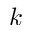<formula> <loc_0><loc_0><loc_500><loc_500>k</formula> 